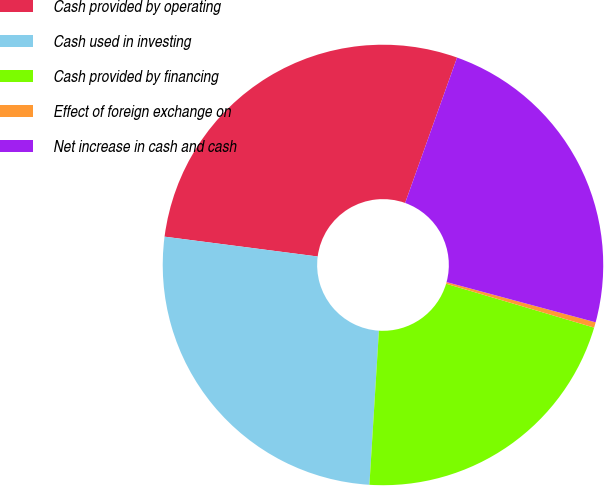<chart> <loc_0><loc_0><loc_500><loc_500><pie_chart><fcel>Cash provided by operating<fcel>Cash used in investing<fcel>Cash provided by financing<fcel>Effect of foreign exchange on<fcel>Net increase in cash and cash<nl><fcel>28.41%<fcel>26.07%<fcel>21.39%<fcel>0.4%<fcel>23.73%<nl></chart> 